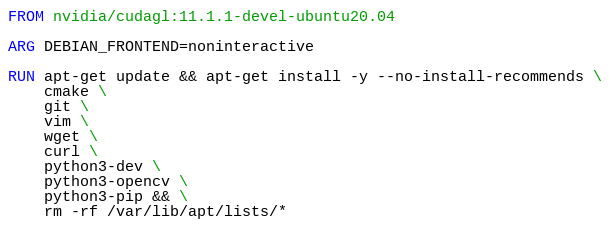<code> <loc_0><loc_0><loc_500><loc_500><_Dockerfile_>FROM nvidia/cudagl:11.1.1-devel-ubuntu20.04

ARG DEBIAN_FRONTEND=noninteractive

RUN apt-get update && apt-get install -y --no-install-recommends \
	cmake \
	git \
	vim \
	wget \
	curl \
	python3-dev \
	python3-opencv \
	python3-pip && \
    rm -rf /var/lib/apt/lists/*
</code> 